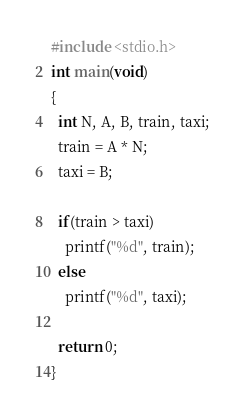<code> <loc_0><loc_0><loc_500><loc_500><_C_>#include <stdio.h>
int main(void)
{
  int N, A, B, train, taxi;
  train = A * N;
  taxi = B;

  if(train > taxi)
    printf("%d", train);
  else
    printf("%d", taxi);

  return 0;
}
</code> 